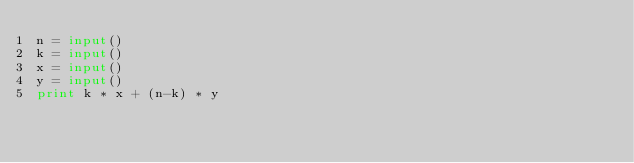<code> <loc_0><loc_0><loc_500><loc_500><_Python_>n = input()
k = input()
x = input()
y = input()
print k * x + (n-k) * y</code> 